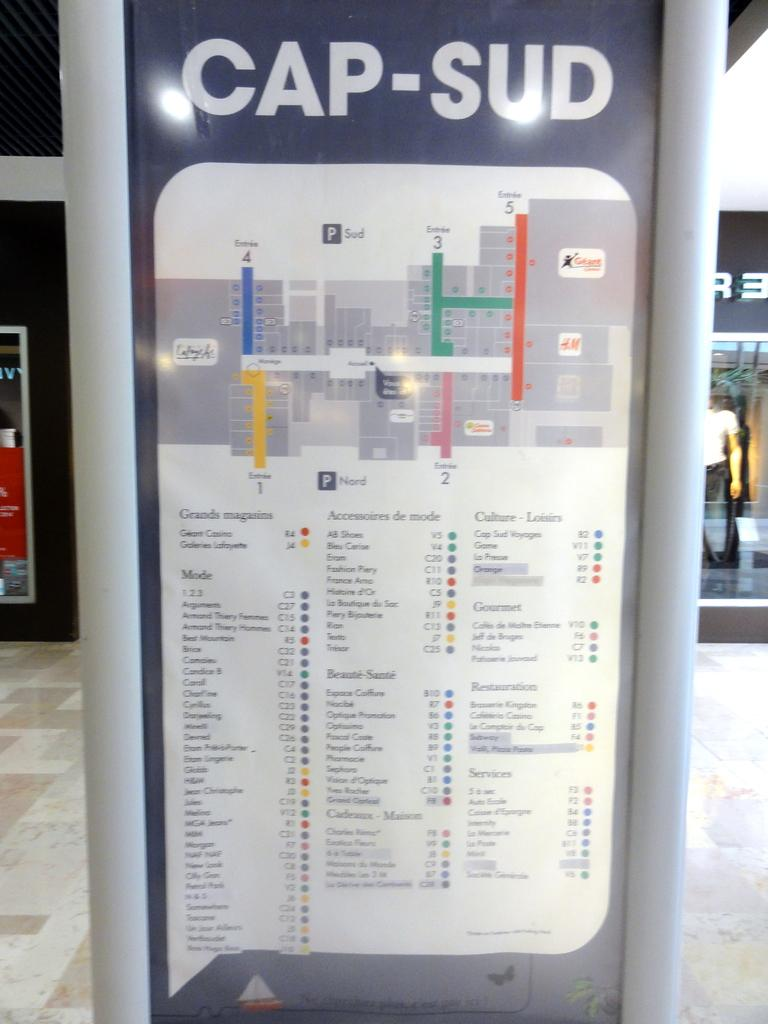What is featured on the poster in the image? There is a poster with an image and text in the image. What can be seen on the ground in the image? The ground is visible in the image. What material is present in the image? There is some glass in the image. What color is the object on the left side of the image? There is a black colored object on the left side of the image. How many eyes can be seen on the cake in the image? There is no cake present in the image, so there are no eyes to count. 